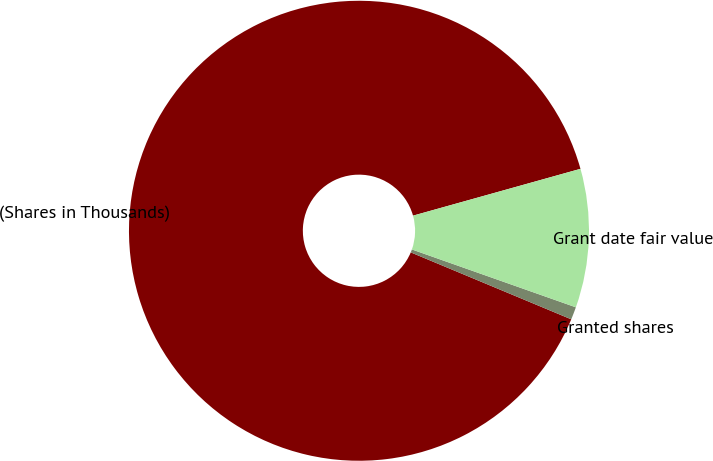Convert chart to OTSL. <chart><loc_0><loc_0><loc_500><loc_500><pie_chart><fcel>(Shares in Thousands)<fcel>Granted shares<fcel>Grant date fair value<nl><fcel>89.38%<fcel>0.89%<fcel>9.74%<nl></chart> 